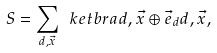Convert formula to latex. <formula><loc_0><loc_0><loc_500><loc_500>S = \sum _ { d , \vec { x } } \ k e t b r a { d , \vec { x } \oplus \vec { e } _ { d } } { d , \vec { x } } ,</formula> 